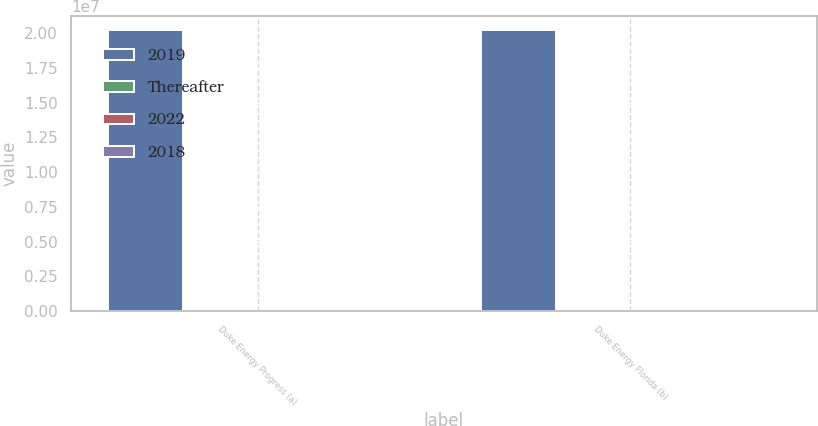Convert chart to OTSL. <chart><loc_0><loc_0><loc_500><loc_500><stacked_bar_chart><ecel><fcel>Duke Energy Progress (a)<fcel>Duke Energy Florida (b)<nl><fcel>2019<fcel>2.0192e+07<fcel>2.0212e+07<nl><fcel>Thereafter<fcel>68<fcel>357<nl><fcel>2022<fcel>68<fcel>374<nl><fcel>2018<fcel>51<fcel>394<nl></chart> 